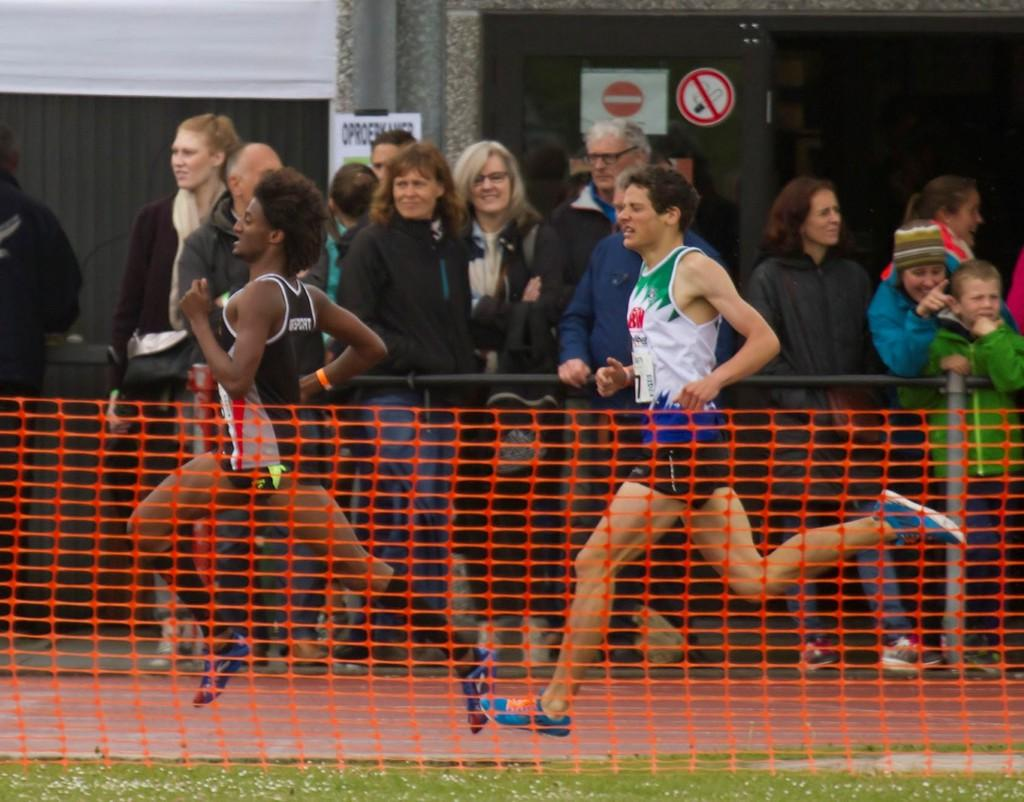What are the people in the image doing? There are people standing in the image, and two people are running on the ground. What is present in the image that might be used for a game? There is a net in the image, which is commonly used in sports like volleyball or tennis. What can be seen in the background of the image? There is a wall with posters in the background. What type of food is being prepared by the people in the image? There is no indication of food preparation in the image; the people are running and standing. Can you see a tin object in the image? There is no tin object present in the image. 